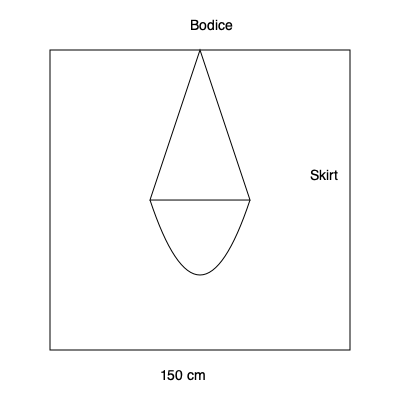Given the silhouette of a custom gown for Kathleen Robertson shown above, with a triangular bodice and a curved skirt, estimate the amount of fabric needed in square meters if the gown's length is 150 cm and the widest part of the skirt is 100 cm. Assume a 20% allowance for seams and draping. To estimate the fabric needed, we'll follow these steps:

1. Calculate the area of the bodice:
   - Approximate the bodice as a triangle
   - Area of triangle = $\frac{1}{2} \times base \times height$
   - Base ≈ 100 cm, Height ≈ 75 cm (half of gown length)
   - Area of bodice = $\frac{1}{2} \times 100 \times 75 = 3750$ cm²

2. Calculate the area of the skirt:
   - Approximate the skirt as a trapezoid
   - Area of trapezoid = $\frac{1}{2}(a+b)h$, where $a$ and $b$ are parallel sides
   - $a$ (top of skirt) ≈ 100 cm, $b$ (bottom of skirt) ≈ 100 cm, $h$ (skirt length) ≈ 75 cm
   - Area of skirt = $\frac{1}{2}(100+100) \times 75 = 7500$ cm²

3. Sum the areas:
   Total area = Bodice + Skirt = $3750 + 7500 = 11250$ cm²

4. Add 20% allowance for seams and draping:
   $11250 \times 1.2 = 13500$ cm²

5. Convert to square meters:
   $13500$ cm² = $1.35$ m²

Therefore, the estimated amount of fabric needed is 1.35 square meters.
Answer: 1.35 m² 